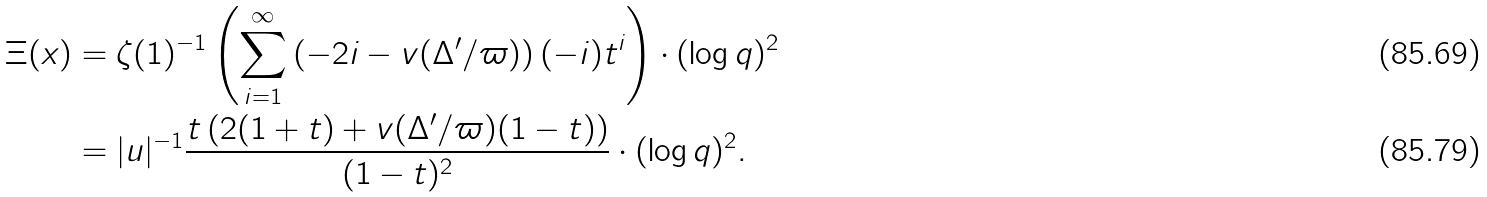<formula> <loc_0><loc_0><loc_500><loc_500>\Xi ( x ) & = \zeta ( 1 ) ^ { - 1 } \left ( \sum _ { i = 1 } ^ { \infty } \left ( - 2 i - v ( \Delta ^ { \prime } / \varpi ) \right ) ( - i ) t ^ { i } \right ) \cdot ( \log q ) ^ { 2 } \\ & = | u | ^ { - 1 } \frac { t \left ( 2 ( 1 + t ) + v ( \Delta ^ { \prime } / \varpi ) ( 1 - t ) \right ) } { ( 1 - t ) ^ { 2 } } \cdot ( \log q ) ^ { 2 } .</formula> 